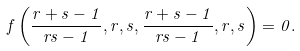<formula> <loc_0><loc_0><loc_500><loc_500>f \left ( \frac { r + s - 1 } { r s - 1 } , r , s , \frac { r + s - 1 } { r s - 1 } , r , s \right ) = 0 .</formula> 